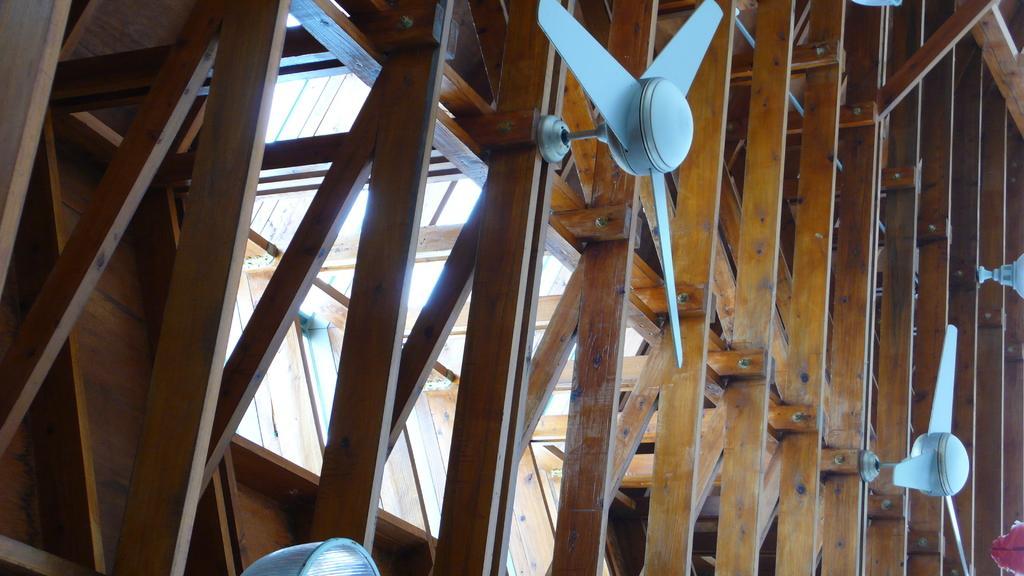How would you summarize this image in a sentence or two? In this image there is a wooden ceiling, for that there are fans and lights. 